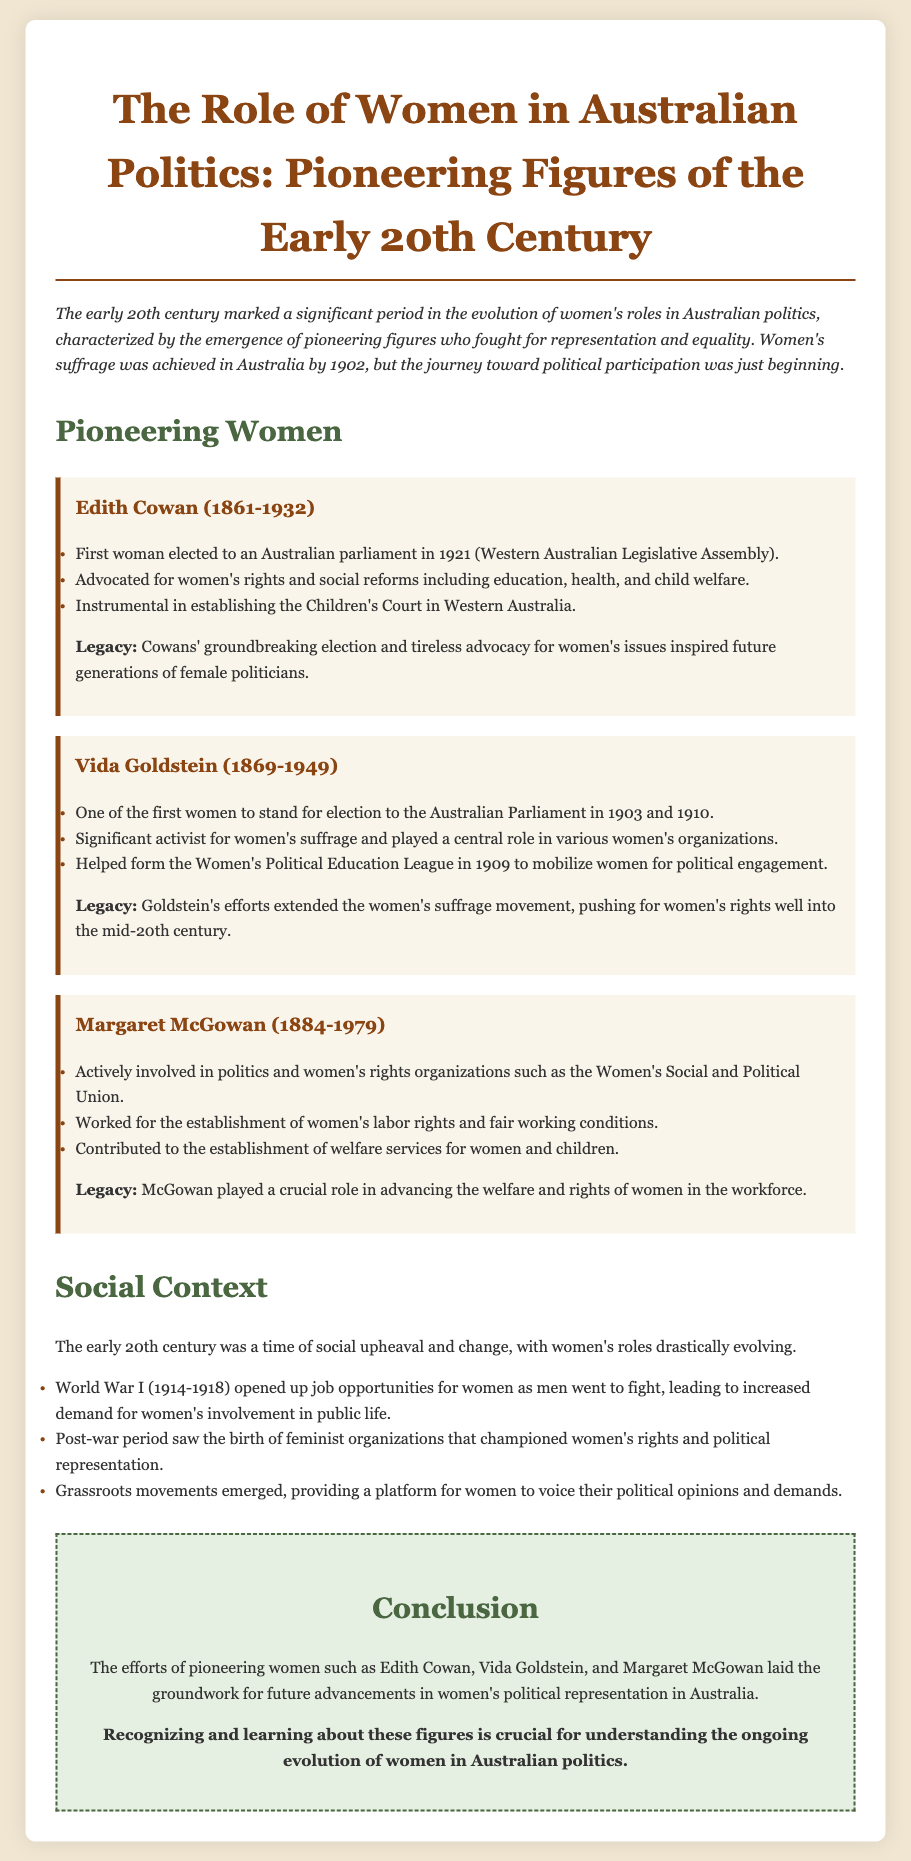What year was Edith Cowan elected to parliament? Edith Cowan was elected in 1921, as mentioned in her contribution to the document under pioneering women.
Answer: 1921 What organization did Vida Goldstein help form in 1909? Vida Goldstein helped form the Women's Political Education League in 1909, highlighted in her section of the document.
Answer: Women's Political Education League What social event increased job opportunities for women during the early 20th century? The document states that World War I opened up job opportunities for women, impacting their roles in society.
Answer: World War I Which pioneering woman was involved with the Women's Social and Political Union? The document specifically mentions Margaret McGowan as being actively involved in the Women's Social and Political Union.
Answer: Margaret McGowan What was a significant legacy of Edith Cowan's advocacy? The document notes that Cowan's groundbreaking election and advocacy inspired future generations of female politicians.
Answer: Inspired future generations What led to the emergence of feminist organizations after World War I? According to the document, the post-war period saw the birth of feminist organizations that championed women's rights and political representation.
Answer: Post-war period Who fought for children's welfare and established the Children's Court in Western Australia? The text clarifies that Edith Cowan was instrumental in establishing the Children's Court, addressing children's welfare issues.
Answer: Edith Cowan What was the focus of enduring grassroots movements mentioned in the document? Grassroots movements emerged, providing a platform for women to voice their political opinions and demands, as described in the social context section.
Answer: Political opinions and demands 